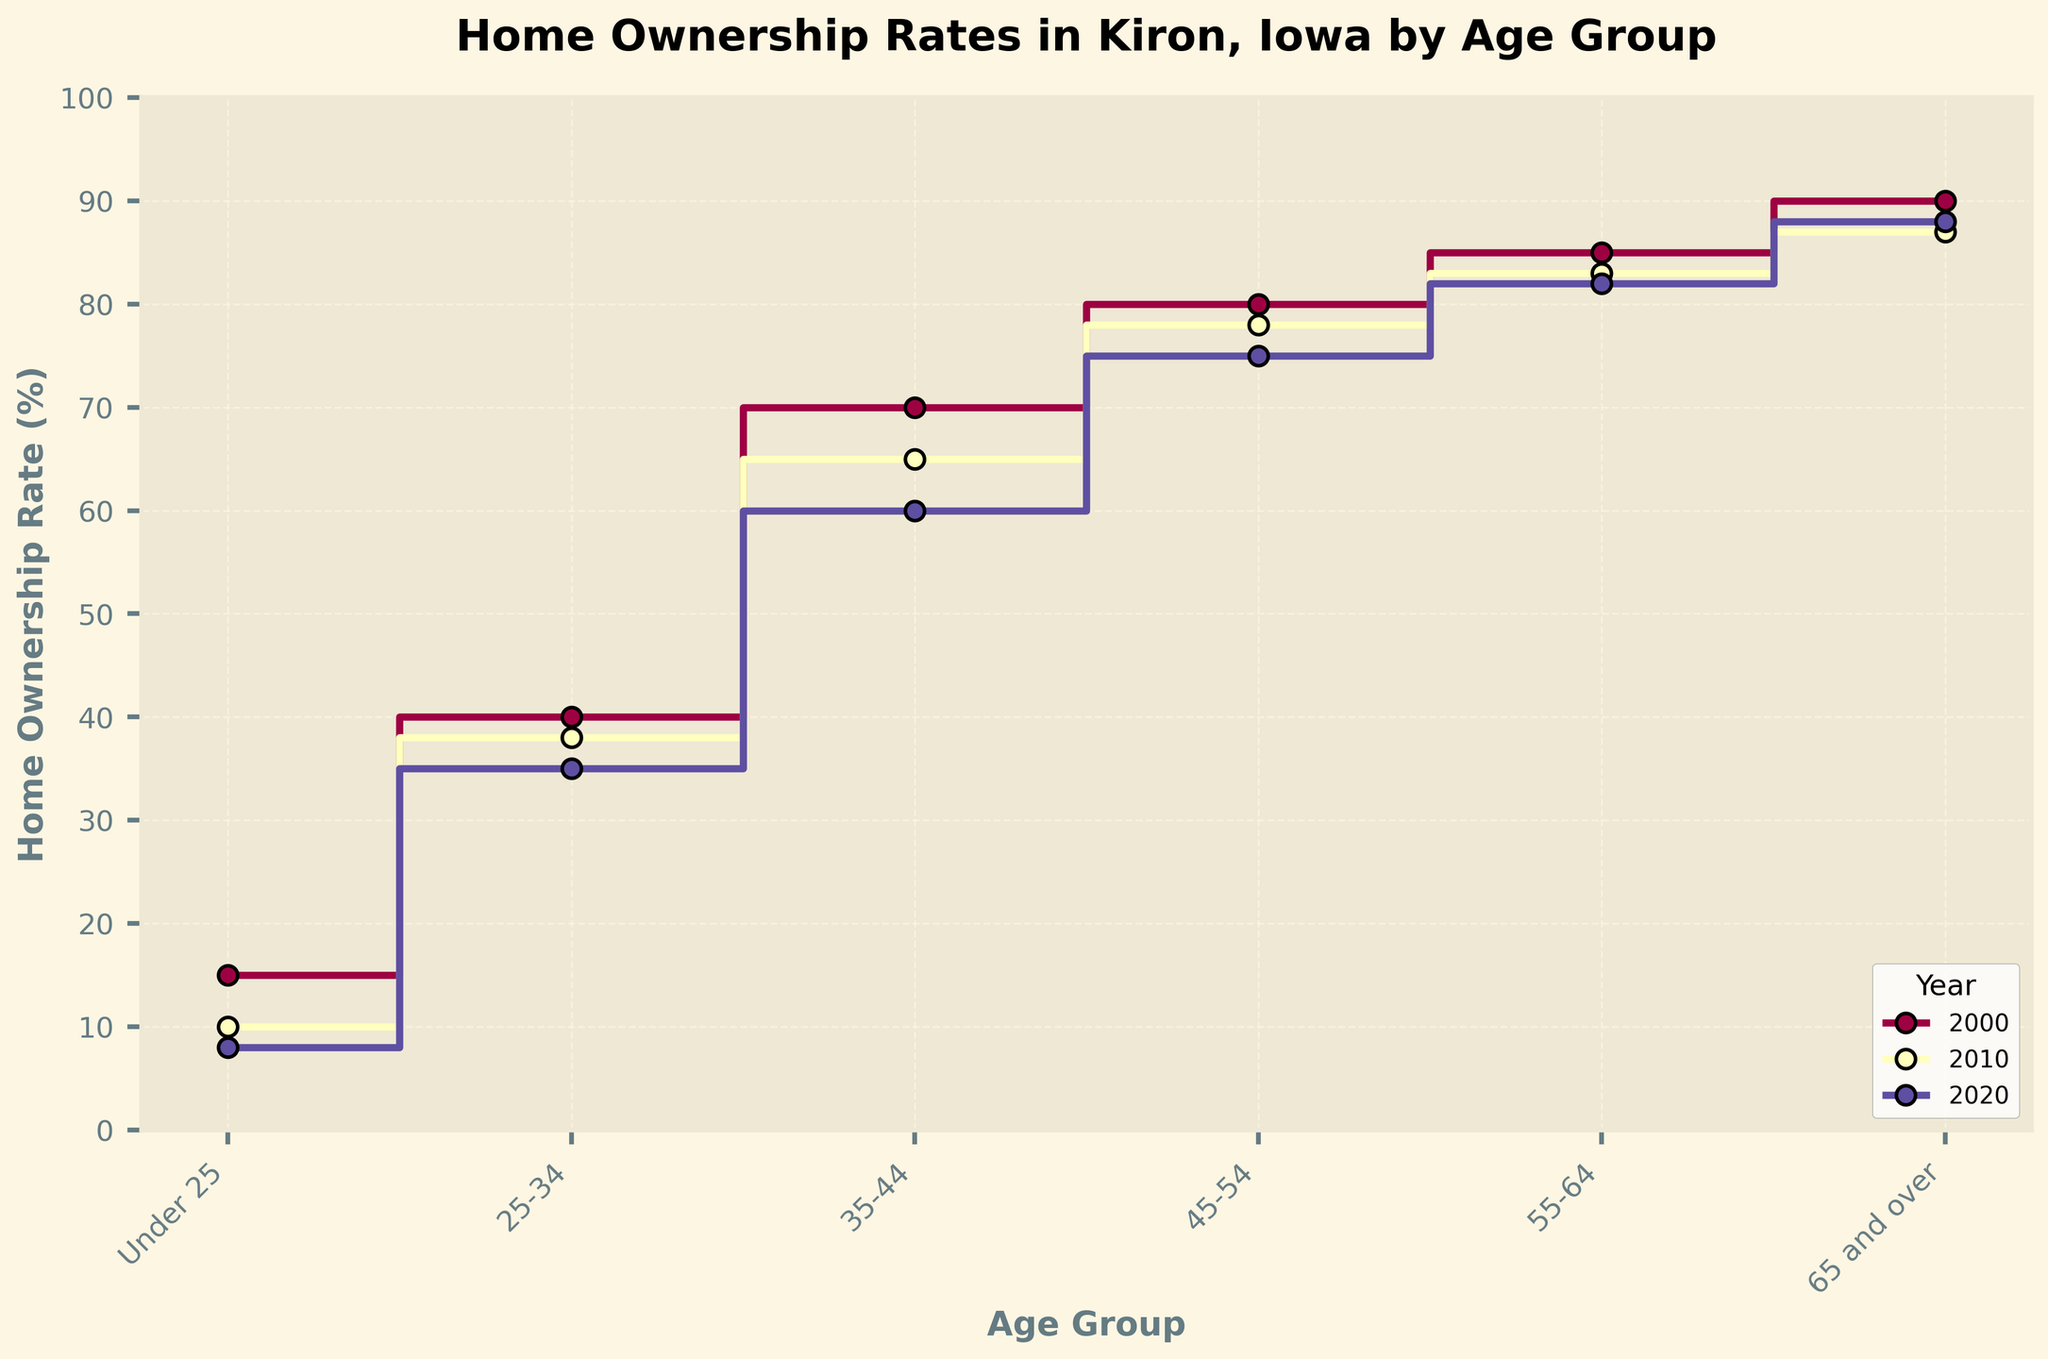What is the title of the plot? The title is located at the top of the plot and gives a summary of what the plot represents.
Answer: Home Ownership Rates in Kiron, Iowa by Age Group What is the range of the y-axis? The y-axis shows the range from the minimum to the maximum value representing home ownership rates. It ranges from 0 to 100 percent.
Answer: 0-100 Which age group had the highest home ownership rate in 2020? By looking at the data points for the year 2020, the group '65 and over' has the highest data point.
Answer: 65 and over Between 2000 and 2020, which age group saw the largest decrease in home ownership rates? For each age group, subtract the rate in 2020 from the rate in 2000 and compare these differences. The 'Under 25' group decreased from 15% to 8%, showing the largest decrease of 7%.
Answer: Under 25 What is the percentage difference in home ownership rate for the 55-64 age group between 2000 and 2020? The rate for the 55-64 age group is 85% in 2000 and 82% in 2020. The difference is calculated as 85 - 82.
Answer: 3% For which age group did the home ownership rate remain relatively stable between 2000 and 2020? To determine stability, compare the numerical differences between rates over the years for each age group. The 65 and over age group saw a decrease from 90% to 88%, which is a small change of 2%.
Answer: 65 and over How many age groups are analyzed in the plot? The x-axis displays different age categories. Counting the distinct groups listed provides the total number.
Answer: 6 Which year had the sharpest decline in home ownership rate for the age group 45-54? Examine the differences between consecutive years for the 45-54 age group. The decline from 80% in 2000 to 78% in 2010, and then to 75% in 2020 shows the sharpest initial decline happened between 2000 and 2010.
Answer: 2010 What is the trend in home ownership rates for the 'Under 25' age group over the three years shown? Track the data points for 'Under 25' from 2000 to 2020 which shows a consistent decrease from 15% to 10% to 8%.
Answer: Decreasing Is there any age group where the home ownership rate in 2020 was higher than in 2010? Compare rates of each age group for these two years. All rates either remained the same or decreased, so no age group had a higher rate in 2020 compared to 2010.
Answer: No 